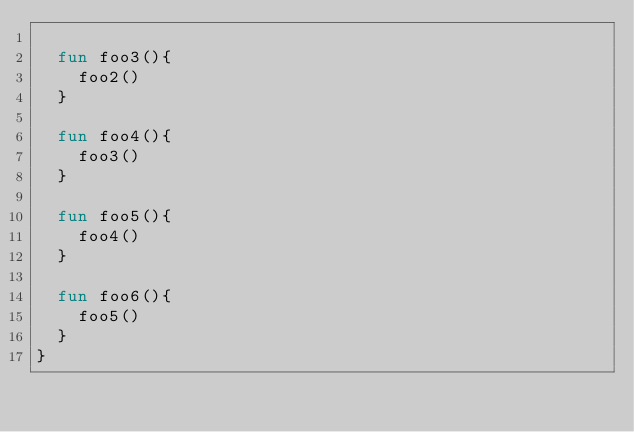<code> <loc_0><loc_0><loc_500><loc_500><_Kotlin_>
  fun foo3(){
    foo2()
  }

  fun foo4(){
    foo3()
  }

  fun foo5(){
    foo4()
  }

  fun foo6(){
    foo5()
  }
}</code> 